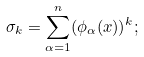<formula> <loc_0><loc_0><loc_500><loc_500>\sigma _ { k } = \sum _ { \alpha = 1 } ^ { n } ( \phi _ { \alpha } ( x ) ) ^ { k } ;</formula> 